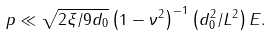Convert formula to latex. <formula><loc_0><loc_0><loc_500><loc_500>p \ll \sqrt { 2 \xi / 9 d _ { 0 } } \left ( 1 - \nu ^ { 2 } \right ) ^ { - 1 } \left ( d _ { 0 } ^ { 2 } / L ^ { 2 } \right ) E .</formula> 